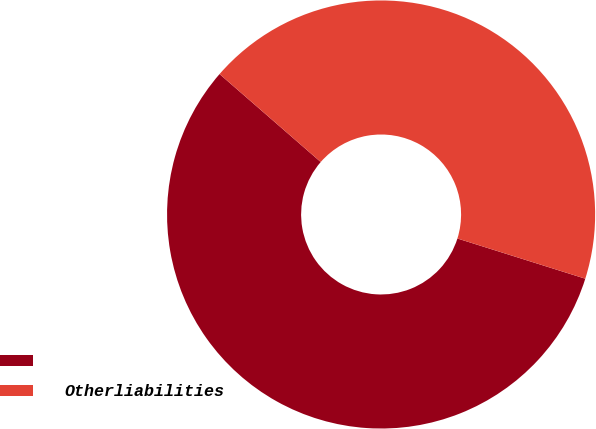Convert chart to OTSL. <chart><loc_0><loc_0><loc_500><loc_500><pie_chart><ecel><fcel>Otherliabilities<nl><fcel>56.54%<fcel>43.46%<nl></chart> 